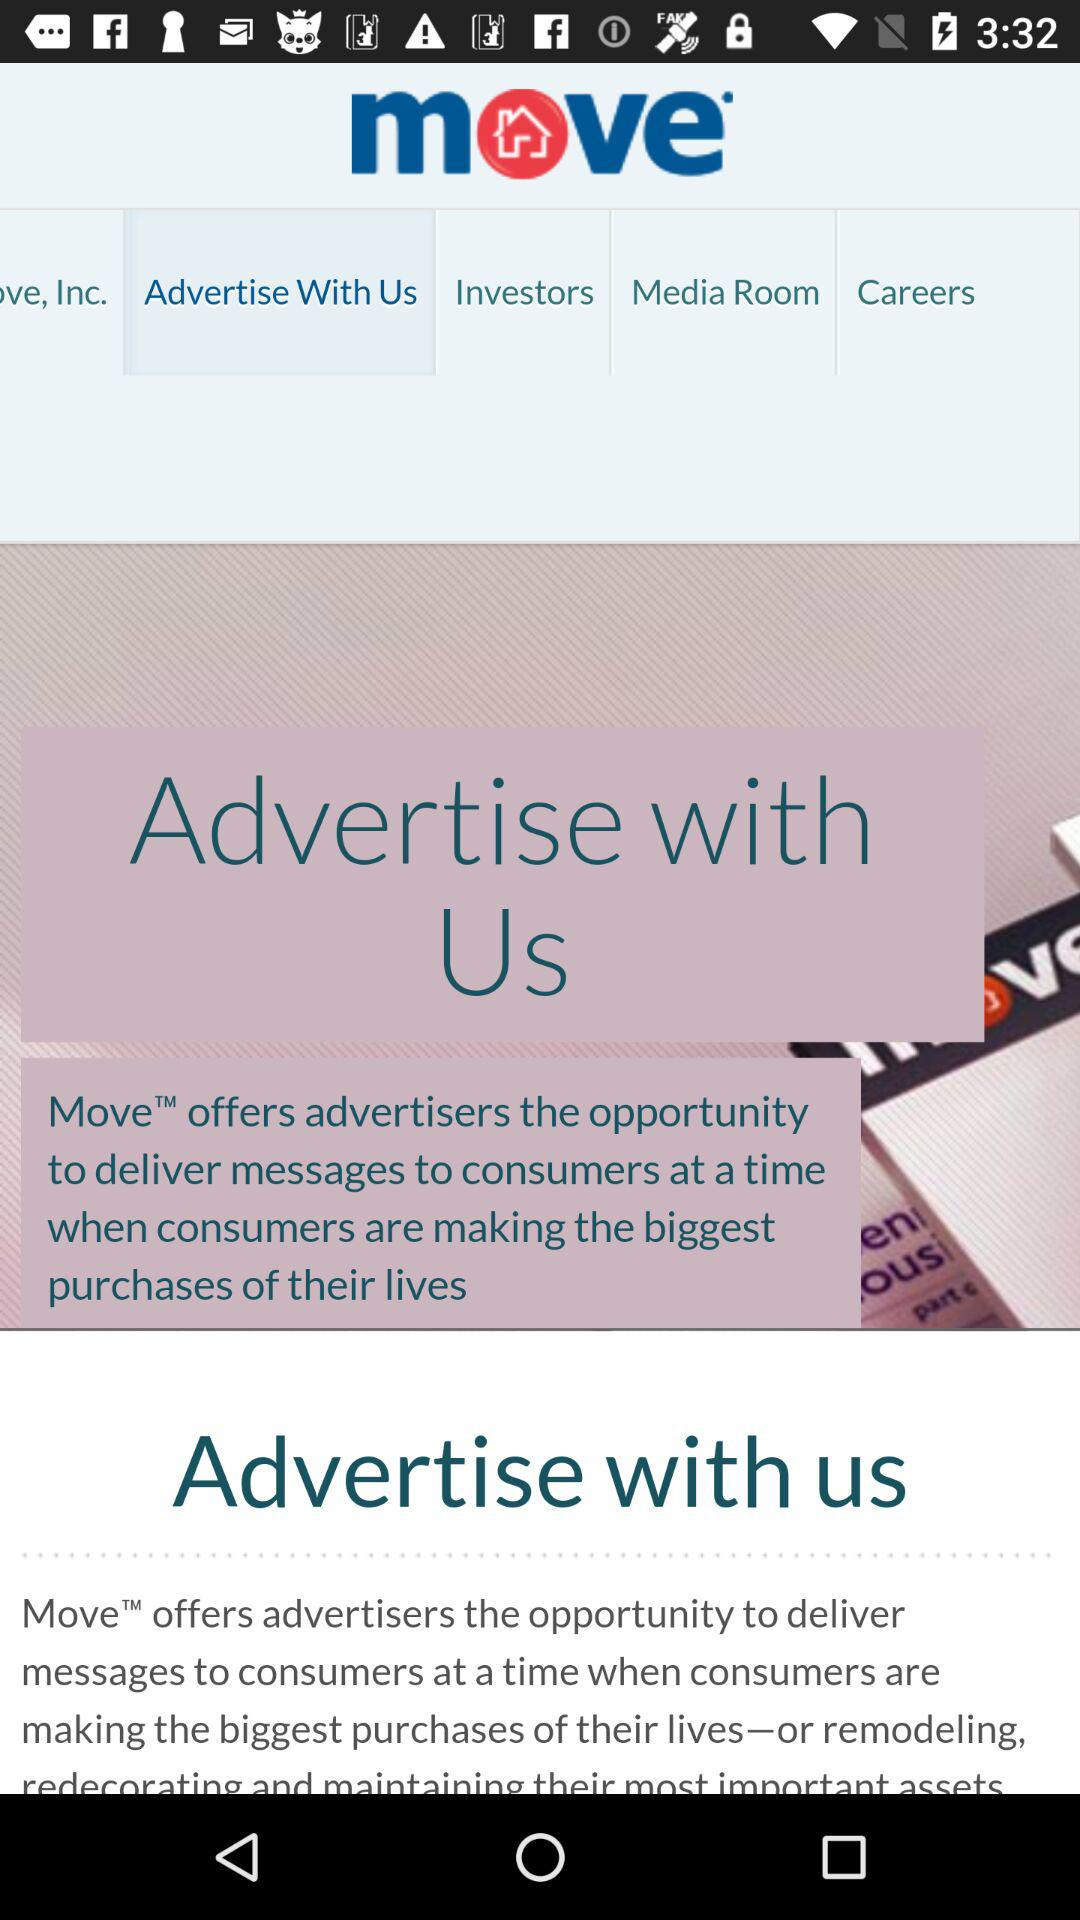Which tab is selected? The selected tab is "Advertise With Us". 